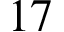<formula> <loc_0><loc_0><loc_500><loc_500>1 7</formula> 